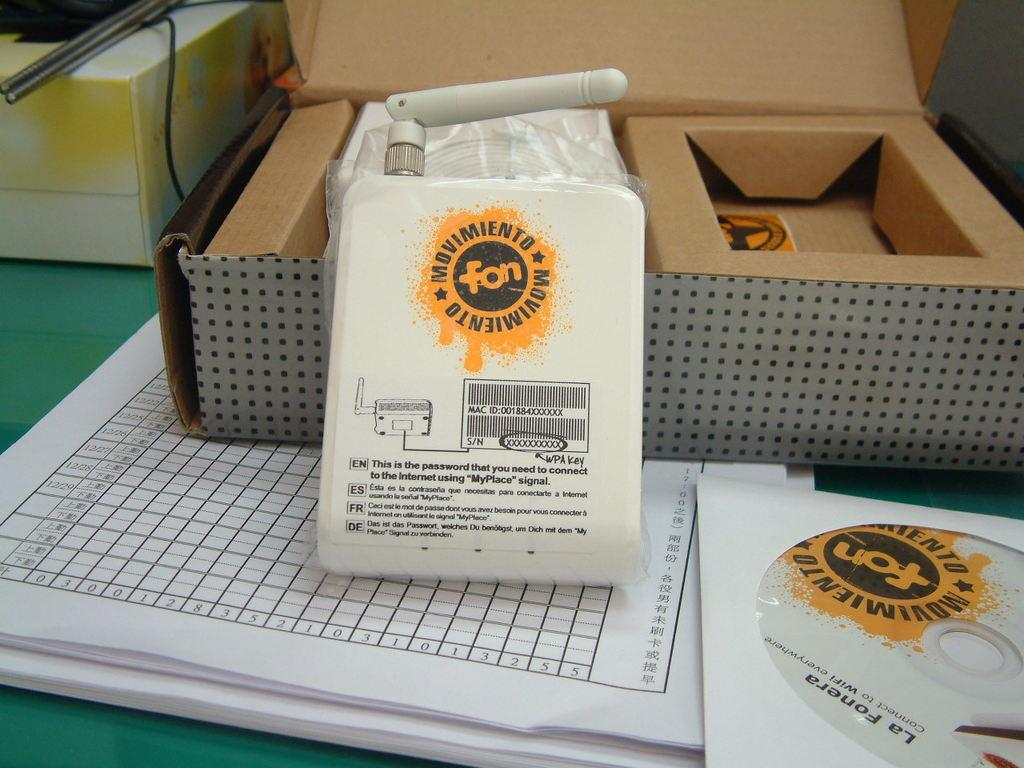<image>
Share a concise interpretation of the image provided. A white router with a yellow logo stating MOVIMIENTO 